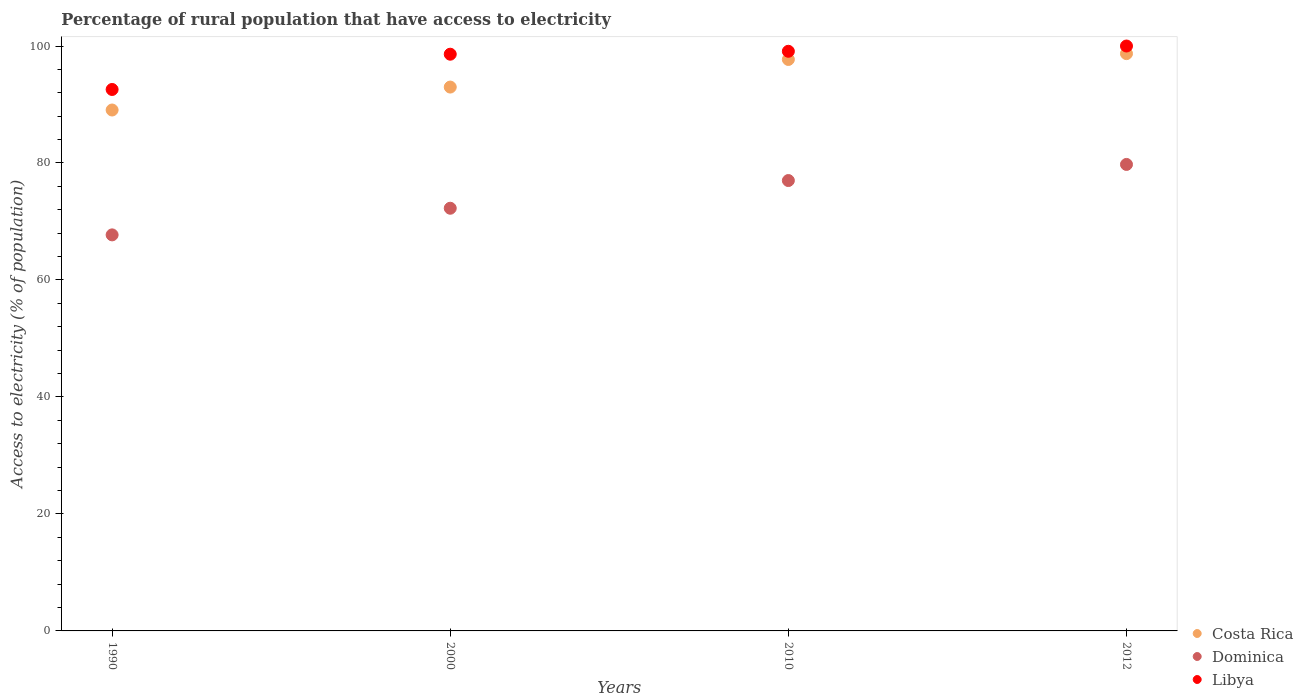Is the number of dotlines equal to the number of legend labels?
Give a very brief answer. Yes. What is the percentage of rural population that have access to electricity in Dominica in 2012?
Your answer should be compact. 79.75. Across all years, what is the maximum percentage of rural population that have access to electricity in Dominica?
Ensure brevity in your answer.  79.75. Across all years, what is the minimum percentage of rural population that have access to electricity in Dominica?
Offer a terse response. 67.71. What is the total percentage of rural population that have access to electricity in Dominica in the graph?
Keep it short and to the point. 296.73. What is the difference between the percentage of rural population that have access to electricity in Dominica in 1990 and that in 2010?
Your answer should be compact. -9.29. What is the difference between the percentage of rural population that have access to electricity in Costa Rica in 2000 and the percentage of rural population that have access to electricity in Dominica in 2012?
Offer a very short reply. 13.23. What is the average percentage of rural population that have access to electricity in Libya per year?
Your answer should be very brief. 97.57. In the year 1990, what is the difference between the percentage of rural population that have access to electricity in Dominica and percentage of rural population that have access to electricity in Libya?
Provide a short and direct response. -24.86. What is the ratio of the percentage of rural population that have access to electricity in Costa Rica in 2000 to that in 2010?
Provide a short and direct response. 0.95. Is the percentage of rural population that have access to electricity in Libya in 2000 less than that in 2010?
Your response must be concise. Yes. Is the difference between the percentage of rural population that have access to electricity in Dominica in 2010 and 2012 greater than the difference between the percentage of rural population that have access to electricity in Libya in 2010 and 2012?
Your answer should be compact. No. What is the difference between the highest and the second highest percentage of rural population that have access to electricity in Libya?
Offer a terse response. 0.9. What is the difference between the highest and the lowest percentage of rural population that have access to electricity in Libya?
Your response must be concise. 7.43. In how many years, is the percentage of rural population that have access to electricity in Dominica greater than the average percentage of rural population that have access to electricity in Dominica taken over all years?
Provide a succinct answer. 2. Is the sum of the percentage of rural population that have access to electricity in Dominica in 2000 and 2010 greater than the maximum percentage of rural population that have access to electricity in Libya across all years?
Offer a very short reply. Yes. Is the percentage of rural population that have access to electricity in Libya strictly greater than the percentage of rural population that have access to electricity in Costa Rica over the years?
Make the answer very short. Yes. Is the percentage of rural population that have access to electricity in Dominica strictly less than the percentage of rural population that have access to electricity in Costa Rica over the years?
Offer a terse response. Yes. How many dotlines are there?
Make the answer very short. 3. What is the difference between two consecutive major ticks on the Y-axis?
Your response must be concise. 20. Where does the legend appear in the graph?
Offer a very short reply. Bottom right. What is the title of the graph?
Provide a succinct answer. Percentage of rural population that have access to electricity. Does "Nigeria" appear as one of the legend labels in the graph?
Your response must be concise. No. What is the label or title of the X-axis?
Keep it short and to the point. Years. What is the label or title of the Y-axis?
Offer a very short reply. Access to electricity (% of population). What is the Access to electricity (% of population) of Costa Rica in 1990?
Offer a terse response. 89.06. What is the Access to electricity (% of population) in Dominica in 1990?
Give a very brief answer. 67.71. What is the Access to electricity (% of population) in Libya in 1990?
Your answer should be compact. 92.57. What is the Access to electricity (% of population) of Costa Rica in 2000?
Your answer should be very brief. 92.98. What is the Access to electricity (% of population) of Dominica in 2000?
Ensure brevity in your answer.  72.27. What is the Access to electricity (% of population) of Libya in 2000?
Make the answer very short. 98.6. What is the Access to electricity (% of population) in Costa Rica in 2010?
Give a very brief answer. 97.7. What is the Access to electricity (% of population) of Dominica in 2010?
Your answer should be very brief. 77. What is the Access to electricity (% of population) in Libya in 2010?
Keep it short and to the point. 99.1. What is the Access to electricity (% of population) of Costa Rica in 2012?
Make the answer very short. 98.7. What is the Access to electricity (% of population) in Dominica in 2012?
Make the answer very short. 79.75. What is the Access to electricity (% of population) in Libya in 2012?
Your answer should be compact. 100. Across all years, what is the maximum Access to electricity (% of population) of Costa Rica?
Keep it short and to the point. 98.7. Across all years, what is the maximum Access to electricity (% of population) in Dominica?
Give a very brief answer. 79.75. Across all years, what is the minimum Access to electricity (% of population) in Costa Rica?
Make the answer very short. 89.06. Across all years, what is the minimum Access to electricity (% of population) in Dominica?
Give a very brief answer. 67.71. Across all years, what is the minimum Access to electricity (% of population) of Libya?
Your response must be concise. 92.57. What is the total Access to electricity (% of population) in Costa Rica in the graph?
Your answer should be very brief. 378.44. What is the total Access to electricity (% of population) of Dominica in the graph?
Make the answer very short. 296.73. What is the total Access to electricity (% of population) of Libya in the graph?
Offer a very short reply. 390.27. What is the difference between the Access to electricity (% of population) in Costa Rica in 1990 and that in 2000?
Ensure brevity in your answer.  -3.92. What is the difference between the Access to electricity (% of population) of Dominica in 1990 and that in 2000?
Keep it short and to the point. -4.55. What is the difference between the Access to electricity (% of population) in Libya in 1990 and that in 2000?
Your answer should be very brief. -6.03. What is the difference between the Access to electricity (% of population) in Costa Rica in 1990 and that in 2010?
Your response must be concise. -8.64. What is the difference between the Access to electricity (% of population) in Dominica in 1990 and that in 2010?
Provide a succinct answer. -9.29. What is the difference between the Access to electricity (% of population) of Libya in 1990 and that in 2010?
Give a very brief answer. -6.53. What is the difference between the Access to electricity (% of population) in Costa Rica in 1990 and that in 2012?
Offer a terse response. -9.64. What is the difference between the Access to electricity (% of population) of Dominica in 1990 and that in 2012?
Offer a very short reply. -12.04. What is the difference between the Access to electricity (% of population) in Libya in 1990 and that in 2012?
Your answer should be compact. -7.43. What is the difference between the Access to electricity (% of population) in Costa Rica in 2000 and that in 2010?
Keep it short and to the point. -4.72. What is the difference between the Access to electricity (% of population) of Dominica in 2000 and that in 2010?
Offer a very short reply. -4.74. What is the difference between the Access to electricity (% of population) of Costa Rica in 2000 and that in 2012?
Your answer should be very brief. -5.72. What is the difference between the Access to electricity (% of population) of Dominica in 2000 and that in 2012?
Offer a very short reply. -7.49. What is the difference between the Access to electricity (% of population) in Libya in 2000 and that in 2012?
Give a very brief answer. -1.4. What is the difference between the Access to electricity (% of population) in Costa Rica in 2010 and that in 2012?
Provide a succinct answer. -1. What is the difference between the Access to electricity (% of population) of Dominica in 2010 and that in 2012?
Make the answer very short. -2.75. What is the difference between the Access to electricity (% of population) in Libya in 2010 and that in 2012?
Your response must be concise. -0.9. What is the difference between the Access to electricity (% of population) in Costa Rica in 1990 and the Access to electricity (% of population) in Dominica in 2000?
Offer a very short reply. 16.8. What is the difference between the Access to electricity (% of population) of Costa Rica in 1990 and the Access to electricity (% of population) of Libya in 2000?
Give a very brief answer. -9.54. What is the difference between the Access to electricity (% of population) of Dominica in 1990 and the Access to electricity (% of population) of Libya in 2000?
Make the answer very short. -30.89. What is the difference between the Access to electricity (% of population) in Costa Rica in 1990 and the Access to electricity (% of population) in Dominica in 2010?
Give a very brief answer. 12.06. What is the difference between the Access to electricity (% of population) of Costa Rica in 1990 and the Access to electricity (% of population) of Libya in 2010?
Provide a short and direct response. -10.04. What is the difference between the Access to electricity (% of population) in Dominica in 1990 and the Access to electricity (% of population) in Libya in 2010?
Provide a succinct answer. -31.39. What is the difference between the Access to electricity (% of population) of Costa Rica in 1990 and the Access to electricity (% of population) of Dominica in 2012?
Your response must be concise. 9.31. What is the difference between the Access to electricity (% of population) in Costa Rica in 1990 and the Access to electricity (% of population) in Libya in 2012?
Provide a succinct answer. -10.94. What is the difference between the Access to electricity (% of population) of Dominica in 1990 and the Access to electricity (% of population) of Libya in 2012?
Offer a very short reply. -32.29. What is the difference between the Access to electricity (% of population) in Costa Rica in 2000 and the Access to electricity (% of population) in Dominica in 2010?
Provide a succinct answer. 15.98. What is the difference between the Access to electricity (% of population) in Costa Rica in 2000 and the Access to electricity (% of population) in Libya in 2010?
Offer a terse response. -6.12. What is the difference between the Access to electricity (% of population) in Dominica in 2000 and the Access to electricity (% of population) in Libya in 2010?
Ensure brevity in your answer.  -26.84. What is the difference between the Access to electricity (% of population) of Costa Rica in 2000 and the Access to electricity (% of population) of Dominica in 2012?
Provide a short and direct response. 13.23. What is the difference between the Access to electricity (% of population) of Costa Rica in 2000 and the Access to electricity (% of population) of Libya in 2012?
Make the answer very short. -7.02. What is the difference between the Access to electricity (% of population) of Dominica in 2000 and the Access to electricity (% of population) of Libya in 2012?
Your answer should be very brief. -27.73. What is the difference between the Access to electricity (% of population) of Costa Rica in 2010 and the Access to electricity (% of population) of Dominica in 2012?
Give a very brief answer. 17.95. What is the difference between the Access to electricity (% of population) in Costa Rica in 2010 and the Access to electricity (% of population) in Libya in 2012?
Your response must be concise. -2.3. What is the average Access to electricity (% of population) of Costa Rica per year?
Provide a short and direct response. 94.61. What is the average Access to electricity (% of population) in Dominica per year?
Make the answer very short. 74.18. What is the average Access to electricity (% of population) of Libya per year?
Your answer should be compact. 97.57. In the year 1990, what is the difference between the Access to electricity (% of population) of Costa Rica and Access to electricity (% of population) of Dominica?
Your response must be concise. 21.35. In the year 1990, what is the difference between the Access to electricity (% of population) of Costa Rica and Access to electricity (% of population) of Libya?
Your response must be concise. -3.51. In the year 1990, what is the difference between the Access to electricity (% of population) of Dominica and Access to electricity (% of population) of Libya?
Offer a terse response. -24.86. In the year 2000, what is the difference between the Access to electricity (% of population) of Costa Rica and Access to electricity (% of population) of Dominica?
Provide a succinct answer. 20.72. In the year 2000, what is the difference between the Access to electricity (% of population) in Costa Rica and Access to electricity (% of population) in Libya?
Provide a short and direct response. -5.62. In the year 2000, what is the difference between the Access to electricity (% of population) of Dominica and Access to electricity (% of population) of Libya?
Keep it short and to the point. -26.34. In the year 2010, what is the difference between the Access to electricity (% of population) of Costa Rica and Access to electricity (% of population) of Dominica?
Give a very brief answer. 20.7. In the year 2010, what is the difference between the Access to electricity (% of population) of Costa Rica and Access to electricity (% of population) of Libya?
Offer a terse response. -1.4. In the year 2010, what is the difference between the Access to electricity (% of population) of Dominica and Access to electricity (% of population) of Libya?
Give a very brief answer. -22.1. In the year 2012, what is the difference between the Access to electricity (% of population) of Costa Rica and Access to electricity (% of population) of Dominica?
Keep it short and to the point. 18.95. In the year 2012, what is the difference between the Access to electricity (% of population) in Dominica and Access to electricity (% of population) in Libya?
Your answer should be very brief. -20.25. What is the ratio of the Access to electricity (% of population) of Costa Rica in 1990 to that in 2000?
Ensure brevity in your answer.  0.96. What is the ratio of the Access to electricity (% of population) of Dominica in 1990 to that in 2000?
Ensure brevity in your answer.  0.94. What is the ratio of the Access to electricity (% of population) of Libya in 1990 to that in 2000?
Ensure brevity in your answer.  0.94. What is the ratio of the Access to electricity (% of population) of Costa Rica in 1990 to that in 2010?
Provide a succinct answer. 0.91. What is the ratio of the Access to electricity (% of population) of Dominica in 1990 to that in 2010?
Give a very brief answer. 0.88. What is the ratio of the Access to electricity (% of population) in Libya in 1990 to that in 2010?
Offer a very short reply. 0.93. What is the ratio of the Access to electricity (% of population) of Costa Rica in 1990 to that in 2012?
Provide a succinct answer. 0.9. What is the ratio of the Access to electricity (% of population) of Dominica in 1990 to that in 2012?
Make the answer very short. 0.85. What is the ratio of the Access to electricity (% of population) in Libya in 1990 to that in 2012?
Your response must be concise. 0.93. What is the ratio of the Access to electricity (% of population) in Costa Rica in 2000 to that in 2010?
Ensure brevity in your answer.  0.95. What is the ratio of the Access to electricity (% of population) of Dominica in 2000 to that in 2010?
Offer a terse response. 0.94. What is the ratio of the Access to electricity (% of population) in Costa Rica in 2000 to that in 2012?
Ensure brevity in your answer.  0.94. What is the ratio of the Access to electricity (% of population) in Dominica in 2000 to that in 2012?
Your answer should be very brief. 0.91. What is the ratio of the Access to electricity (% of population) in Libya in 2000 to that in 2012?
Provide a short and direct response. 0.99. What is the ratio of the Access to electricity (% of population) of Dominica in 2010 to that in 2012?
Offer a terse response. 0.97. What is the ratio of the Access to electricity (% of population) of Libya in 2010 to that in 2012?
Your response must be concise. 0.99. What is the difference between the highest and the second highest Access to electricity (% of population) in Costa Rica?
Your answer should be very brief. 1. What is the difference between the highest and the second highest Access to electricity (% of population) of Dominica?
Provide a succinct answer. 2.75. What is the difference between the highest and the lowest Access to electricity (% of population) of Costa Rica?
Make the answer very short. 9.64. What is the difference between the highest and the lowest Access to electricity (% of population) in Dominica?
Offer a very short reply. 12.04. What is the difference between the highest and the lowest Access to electricity (% of population) of Libya?
Make the answer very short. 7.43. 